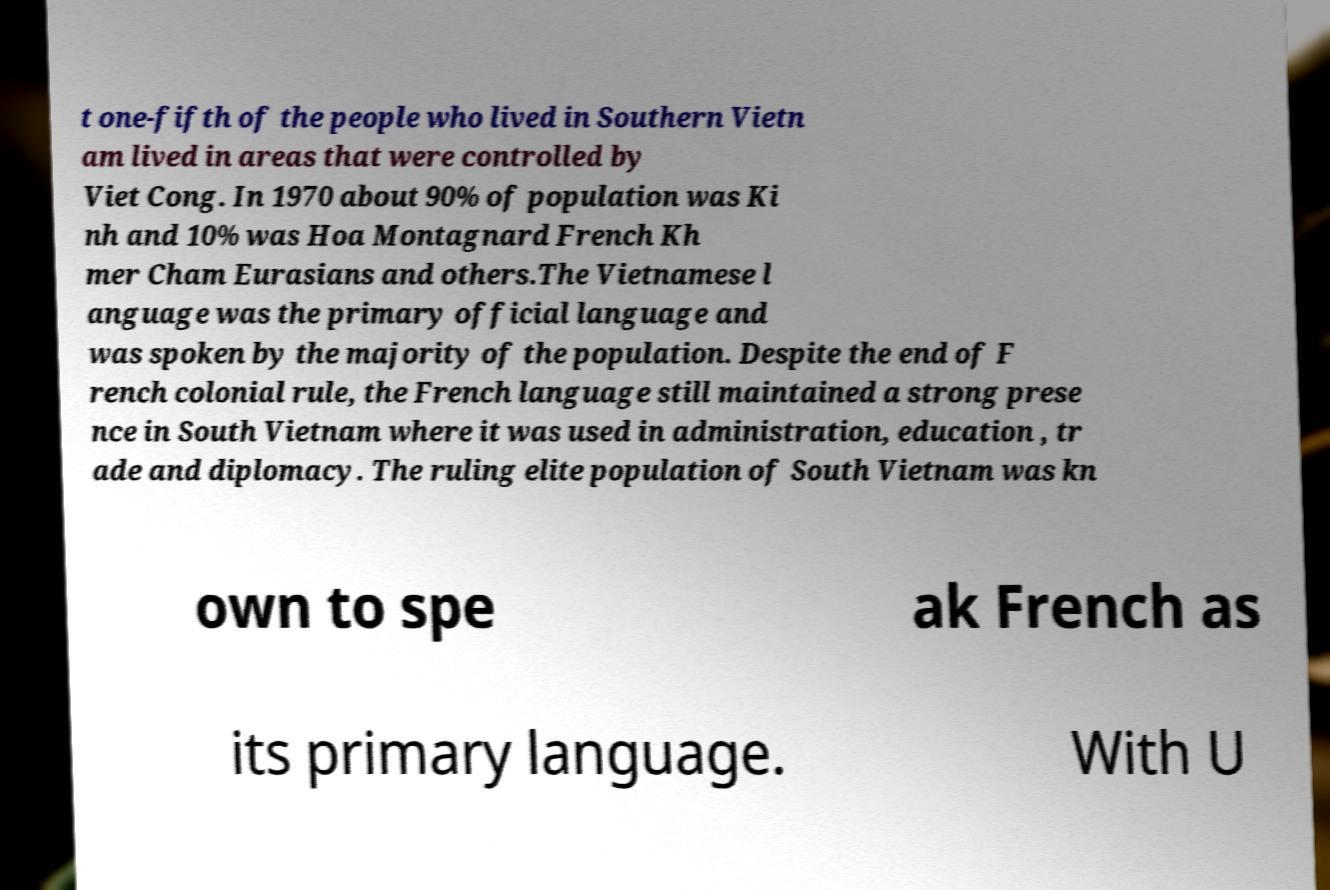Can you read and provide the text displayed in the image?This photo seems to have some interesting text. Can you extract and type it out for me? t one-fifth of the people who lived in Southern Vietn am lived in areas that were controlled by Viet Cong. In 1970 about 90% of population was Ki nh and 10% was Hoa Montagnard French Kh mer Cham Eurasians and others.The Vietnamese l anguage was the primary official language and was spoken by the majority of the population. Despite the end of F rench colonial rule, the French language still maintained a strong prese nce in South Vietnam where it was used in administration, education , tr ade and diplomacy. The ruling elite population of South Vietnam was kn own to spe ak French as its primary language. With U 